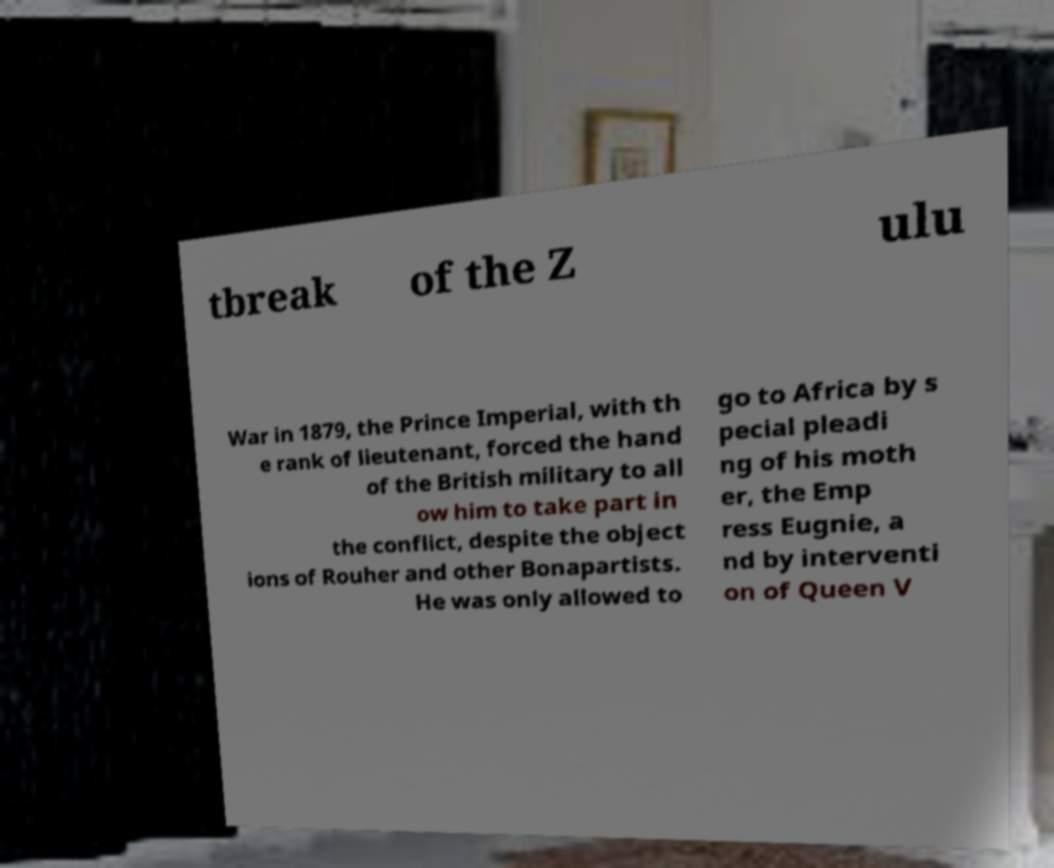There's text embedded in this image that I need extracted. Can you transcribe it verbatim? tbreak of the Z ulu War in 1879, the Prince Imperial, with th e rank of lieutenant, forced the hand of the British military to all ow him to take part in the conflict, despite the object ions of Rouher and other Bonapartists. He was only allowed to go to Africa by s pecial pleadi ng of his moth er, the Emp ress Eugnie, a nd by interventi on of Queen V 